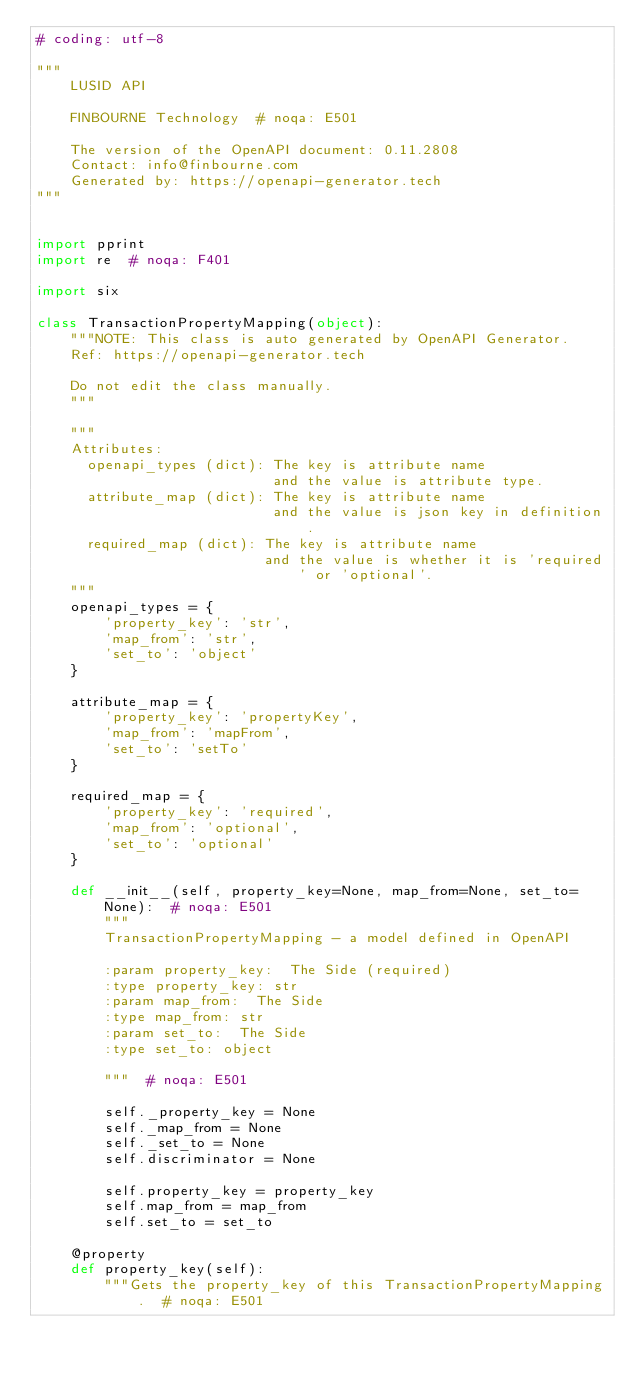Convert code to text. <code><loc_0><loc_0><loc_500><loc_500><_Python_># coding: utf-8

"""
    LUSID API

    FINBOURNE Technology  # noqa: E501

    The version of the OpenAPI document: 0.11.2808
    Contact: info@finbourne.com
    Generated by: https://openapi-generator.tech
"""


import pprint
import re  # noqa: F401

import six

class TransactionPropertyMapping(object):
    """NOTE: This class is auto generated by OpenAPI Generator.
    Ref: https://openapi-generator.tech

    Do not edit the class manually.
    """

    """
    Attributes:
      openapi_types (dict): The key is attribute name
                            and the value is attribute type.
      attribute_map (dict): The key is attribute name
                            and the value is json key in definition.
      required_map (dict): The key is attribute name
                           and the value is whether it is 'required' or 'optional'.
    """
    openapi_types = {
        'property_key': 'str',
        'map_from': 'str',
        'set_to': 'object'
    }

    attribute_map = {
        'property_key': 'propertyKey',
        'map_from': 'mapFrom',
        'set_to': 'setTo'
    }

    required_map = {
        'property_key': 'required',
        'map_from': 'optional',
        'set_to': 'optional'
    }

    def __init__(self, property_key=None, map_from=None, set_to=None):  # noqa: E501
        """
        TransactionPropertyMapping - a model defined in OpenAPI

        :param property_key:  The Side (required)
        :type property_key: str
        :param map_from:  The Side
        :type map_from: str
        :param set_to:  The Side
        :type set_to: object

        """  # noqa: E501

        self._property_key = None
        self._map_from = None
        self._set_to = None
        self.discriminator = None

        self.property_key = property_key
        self.map_from = map_from
        self.set_to = set_to

    @property
    def property_key(self):
        """Gets the property_key of this TransactionPropertyMapping.  # noqa: E501
</code> 